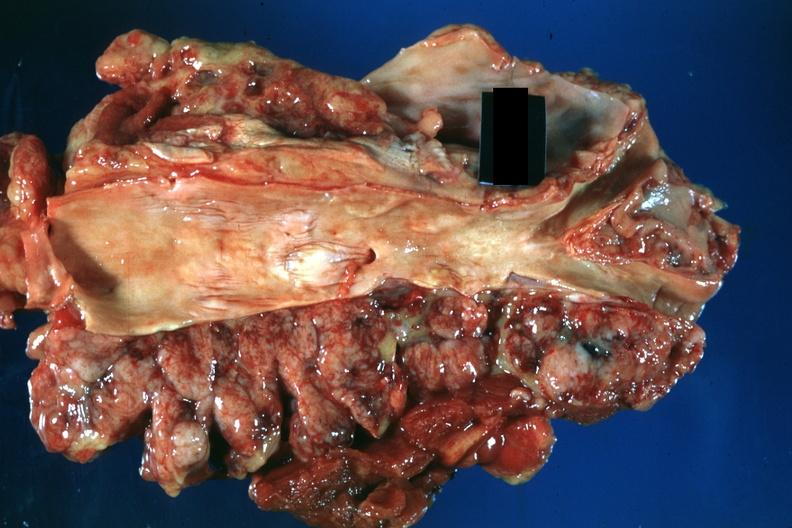what does this image show?
Answer the question using a single word or phrase. Masses of periaortic nodes natural color good 